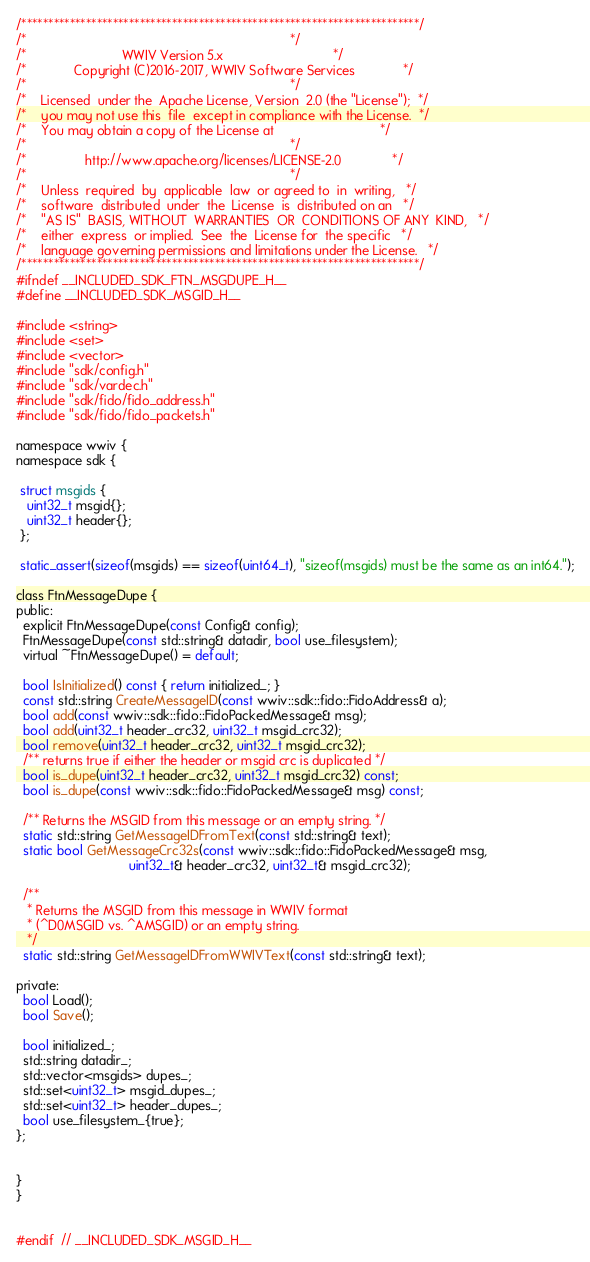Convert code to text. <code><loc_0><loc_0><loc_500><loc_500><_C_>/**************************************************************************/
/*                                                                        */
/*                          WWIV Version 5.x                              */
/*             Copyright (C)2016-2017, WWIV Software Services             */
/*                                                                        */
/*    Licensed  under the  Apache License, Version  2.0 (the "License");  */
/*    you may not use this  file  except in compliance with the License.  */
/*    You may obtain a copy of the License at                             */
/*                                                                        */
/*                http://www.apache.org/licenses/LICENSE-2.0              */
/*                                                                        */
/*    Unless  required  by  applicable  law  or agreed to  in  writing,   */
/*    software  distributed  under  the  License  is  distributed on an   */
/*    "AS IS"  BASIS, WITHOUT  WARRANTIES  OR  CONDITIONS OF ANY  KIND,   */
/*    either  express  or implied.  See  the  License for  the specific   */
/*    language governing permissions and limitations under the License.   */
/**************************************************************************/
#ifndef __INCLUDED_SDK_FTN_MSGDUPE_H__
#define __INCLUDED_SDK_MSGID_H__

#include <string>
#include <set>
#include <vector>
#include "sdk/config.h"
#include "sdk/vardec.h"
#include "sdk/fido/fido_address.h"
#include "sdk/fido/fido_packets.h"

namespace wwiv {
namespace sdk {

 struct msgids {
   uint32_t msgid{};
   uint32_t header{};
 };

 static_assert(sizeof(msgids) == sizeof(uint64_t), "sizeof(msgids) must be the same as an int64.");

class FtnMessageDupe {
public:
  explicit FtnMessageDupe(const Config& config);
  FtnMessageDupe(const std::string& datadir, bool use_filesystem);
  virtual ~FtnMessageDupe() = default;

  bool IsInitialized() const { return initialized_; }
  const std::string CreateMessageID(const wwiv::sdk::fido::FidoAddress& a);
  bool add(const wwiv::sdk::fido::FidoPackedMessage& msg);
  bool add(uint32_t header_crc32, uint32_t msgid_crc32);
  bool remove(uint32_t header_crc32, uint32_t msgid_crc32);
  /** returns true if either the header or msgid crc is duplicated */
  bool is_dupe(uint32_t header_crc32, uint32_t msgid_crc32) const;
  bool is_dupe(const wwiv::sdk::fido::FidoPackedMessage& msg) const;

  /** Returns the MSGID from this message or an empty string. */
  static std::string GetMessageIDFromText(const std::string& text);
  static bool GetMessageCrc32s(const wwiv::sdk::fido::FidoPackedMessage& msg,
                               uint32_t& header_crc32, uint32_t& msgid_crc32);

  /**
   * Returns the MSGID from this message in WWIV format 
   * (^D0MSGID vs. ^AMSGID) or an empty string.
   */
  static std::string GetMessageIDFromWWIVText(const std::string& text);

private:
  bool Load();
  bool Save();

  bool initialized_;
  std::string datadir_;
  std::vector<msgids> dupes_;
  std::set<uint32_t> msgid_dupes_;
  std::set<uint32_t> header_dupes_;
  bool use_filesystem_{true};
};


}
}


#endif  // __INCLUDED_SDK_MSGID_H__
</code> 